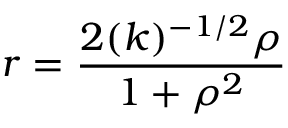Convert formula to latex. <formula><loc_0><loc_0><loc_500><loc_500>r = \frac { 2 ( k ) ^ { - 1 / 2 } { \rho } } { 1 + { \rho } ^ { 2 } }</formula> 